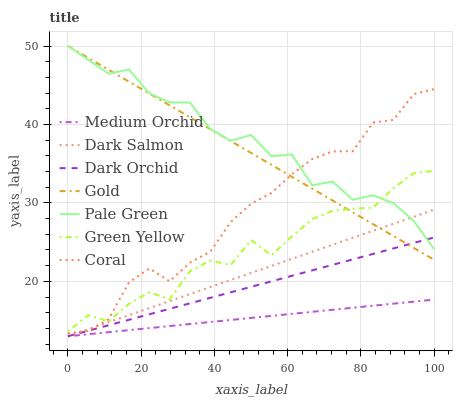Does Coral have the minimum area under the curve?
Answer yes or no. No. Does Coral have the maximum area under the curve?
Answer yes or no. No. Is Coral the smoothest?
Answer yes or no. No. Is Coral the roughest?
Answer yes or no. No. Does Coral have the lowest value?
Answer yes or no. No. Does Coral have the highest value?
Answer yes or no. No. Is Dark Orchid less than Green Yellow?
Answer yes or no. Yes. Is Gold greater than Medium Orchid?
Answer yes or no. Yes. Does Dark Orchid intersect Green Yellow?
Answer yes or no. No. 